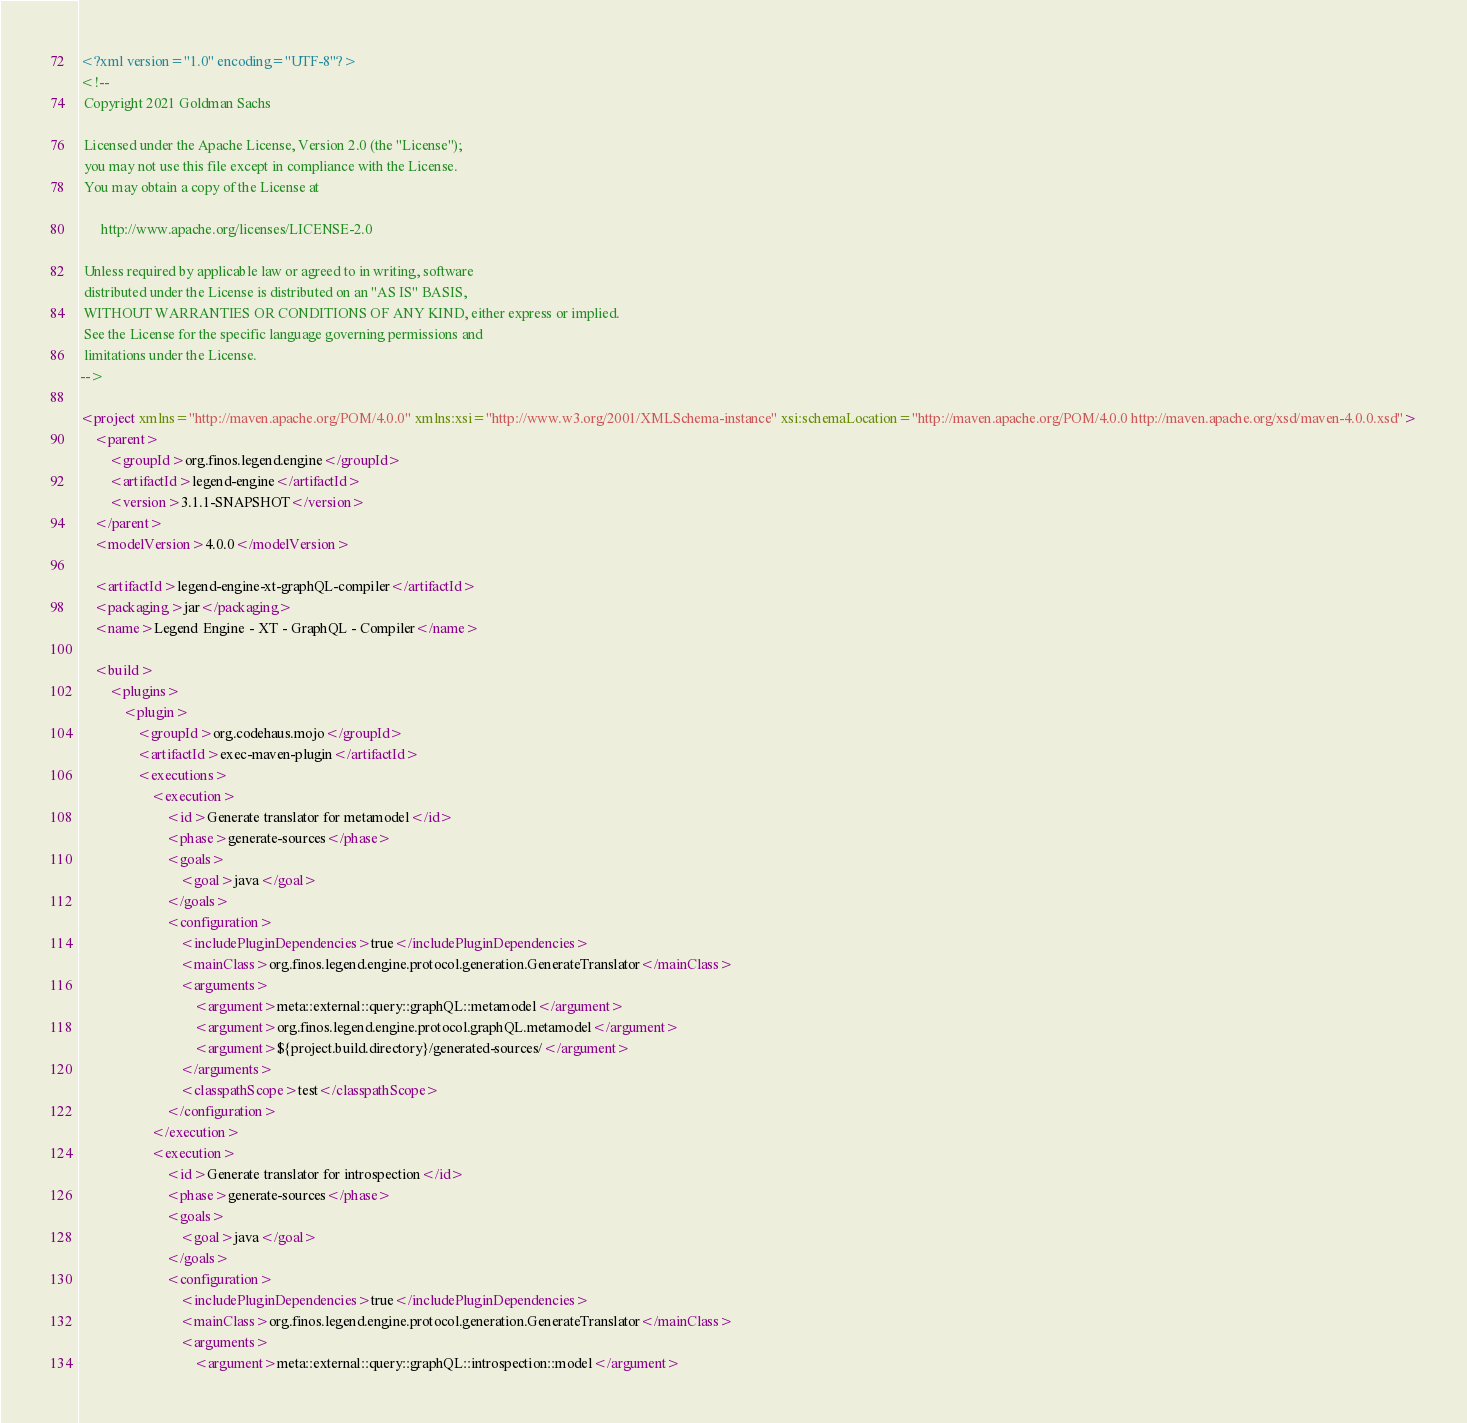<code> <loc_0><loc_0><loc_500><loc_500><_XML_><?xml version="1.0" encoding="UTF-8"?>
<!--
 Copyright 2021 Goldman Sachs

 Licensed under the Apache License, Version 2.0 (the "License");
 you may not use this file except in compliance with the License.
 You may obtain a copy of the License at

      http://www.apache.org/licenses/LICENSE-2.0

 Unless required by applicable law or agreed to in writing, software
 distributed under the License is distributed on an "AS IS" BASIS,
 WITHOUT WARRANTIES OR CONDITIONS OF ANY KIND, either express or implied.
 See the License for the specific language governing permissions and
 limitations under the License.
-->

<project xmlns="http://maven.apache.org/POM/4.0.0" xmlns:xsi="http://www.w3.org/2001/XMLSchema-instance" xsi:schemaLocation="http://maven.apache.org/POM/4.0.0 http://maven.apache.org/xsd/maven-4.0.0.xsd">
    <parent>
        <groupId>org.finos.legend.engine</groupId>
        <artifactId>legend-engine</artifactId>
        <version>3.1.1-SNAPSHOT</version>
    </parent>
    <modelVersion>4.0.0</modelVersion>

    <artifactId>legend-engine-xt-graphQL-compiler</artifactId>
    <packaging>jar</packaging>
    <name>Legend Engine - XT - GraphQL - Compiler</name>

    <build>
        <plugins>
            <plugin>
                <groupId>org.codehaus.mojo</groupId>
                <artifactId>exec-maven-plugin</artifactId>
                <executions>
                    <execution>
                        <id>Generate translator for metamodel</id>
                        <phase>generate-sources</phase>
                        <goals>
                            <goal>java</goal>
                        </goals>
                        <configuration>
                            <includePluginDependencies>true</includePluginDependencies>
                            <mainClass>org.finos.legend.engine.protocol.generation.GenerateTranslator</mainClass>
                            <arguments>
                                <argument>meta::external::query::graphQL::metamodel</argument>
                                <argument>org.finos.legend.engine.protocol.graphQL.metamodel</argument>
                                <argument>${project.build.directory}/generated-sources/</argument>
                            </arguments>
                            <classpathScope>test</classpathScope>
                        </configuration>
                    </execution>
                    <execution>
                        <id>Generate translator for introspection</id>
                        <phase>generate-sources</phase>
                        <goals>
                            <goal>java</goal>
                        </goals>
                        <configuration>
                            <includePluginDependencies>true</includePluginDependencies>
                            <mainClass>org.finos.legend.engine.protocol.generation.GenerateTranslator</mainClass>
                            <arguments>
                                <argument>meta::external::query::graphQL::introspection::model</argument></code> 